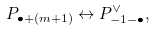Convert formula to latex. <formula><loc_0><loc_0><loc_500><loc_500>P _ { \bullet + ( m + 1 ) } \leftrightarrow P _ { - 1 - \bullet } ^ { \vee } ,</formula> 